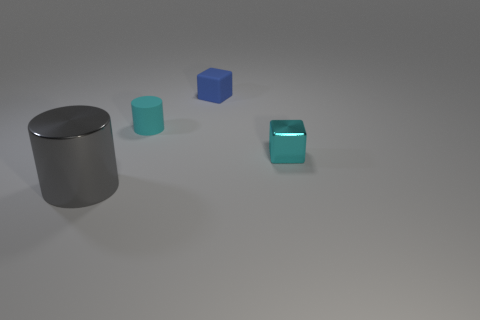Add 4 cyan shiny blocks. How many cyan shiny blocks exist? 5 Add 1 cyan blocks. How many objects exist? 5 Subtract all cyan cylinders. How many cylinders are left? 1 Subtract 0 cyan spheres. How many objects are left? 4 Subtract 2 cylinders. How many cylinders are left? 0 Subtract all gray cylinders. Subtract all brown cubes. How many cylinders are left? 1 Subtract all cyan cylinders. How many blue cubes are left? 1 Subtract all big gray metal cubes. Subtract all metallic cylinders. How many objects are left? 3 Add 2 blue matte blocks. How many blue matte blocks are left? 3 